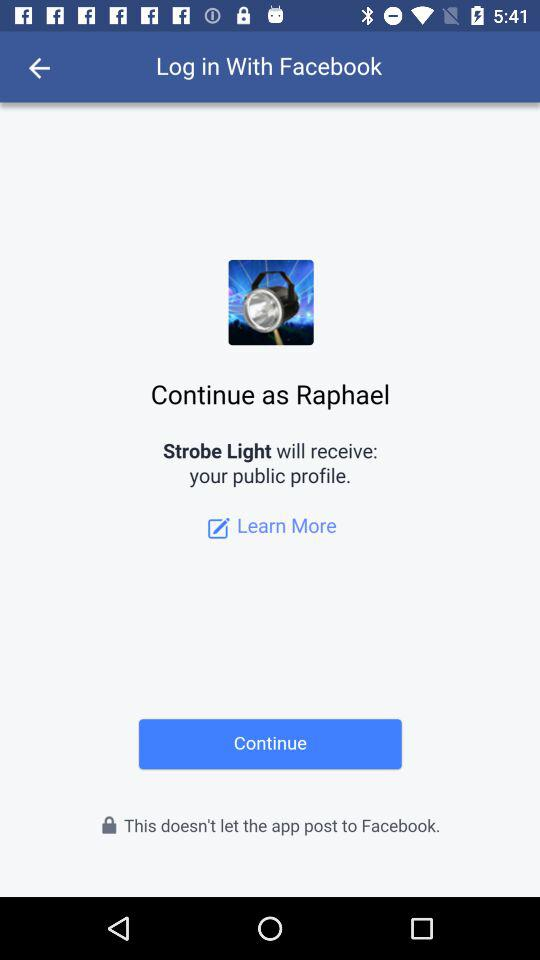What is the login name? The login name is Raphael. 